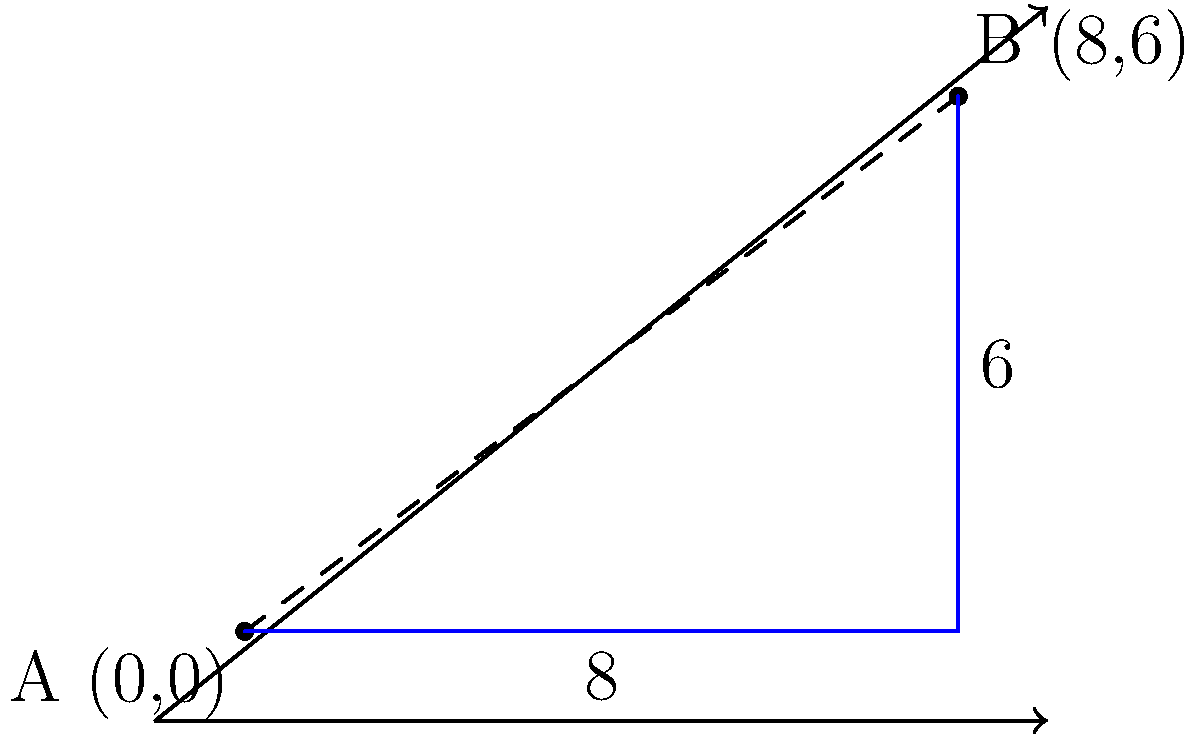As a property owner overseeing repairs, you need to determine the distance between two repair sites on your property. Site A is located at coordinates (0,0) and site B is at (8,6). Using the distance formula, calculate the straight-line distance between these two repair sites. Round your answer to two decimal places. To solve this problem, we'll use the distance formula derived from the Pythagorean theorem:

$$ d = \sqrt{(x_2 - x_1)^2 + (y_2 - y_1)^2} $$

Where $(x_1, y_1)$ are the coordinates of the first point and $(x_2, y_2)$ are the coordinates of the second point.

Step 1: Identify the coordinates
- Site A: $(x_1, y_1) = (0, 0)$
- Site B: $(x_2, y_2) = (8, 6)$

Step 2: Plug the coordinates into the distance formula
$$ d = \sqrt{(8 - 0)^2 + (6 - 0)^2} $$

Step 3: Simplify the expressions inside the parentheses
$$ d = \sqrt{8^2 + 6^2} $$

Step 4: Calculate the squares
$$ d = \sqrt{64 + 36} $$

Step 5: Add the numbers under the square root
$$ d = \sqrt{100} $$

Step 6: Calculate the square root
$$ d = 10 $$

The exact distance between the two repair sites is 10 units (assuming the coordinate grid represents appropriate units of measurement for your property, such as meters or feet).
Answer: 10 units 